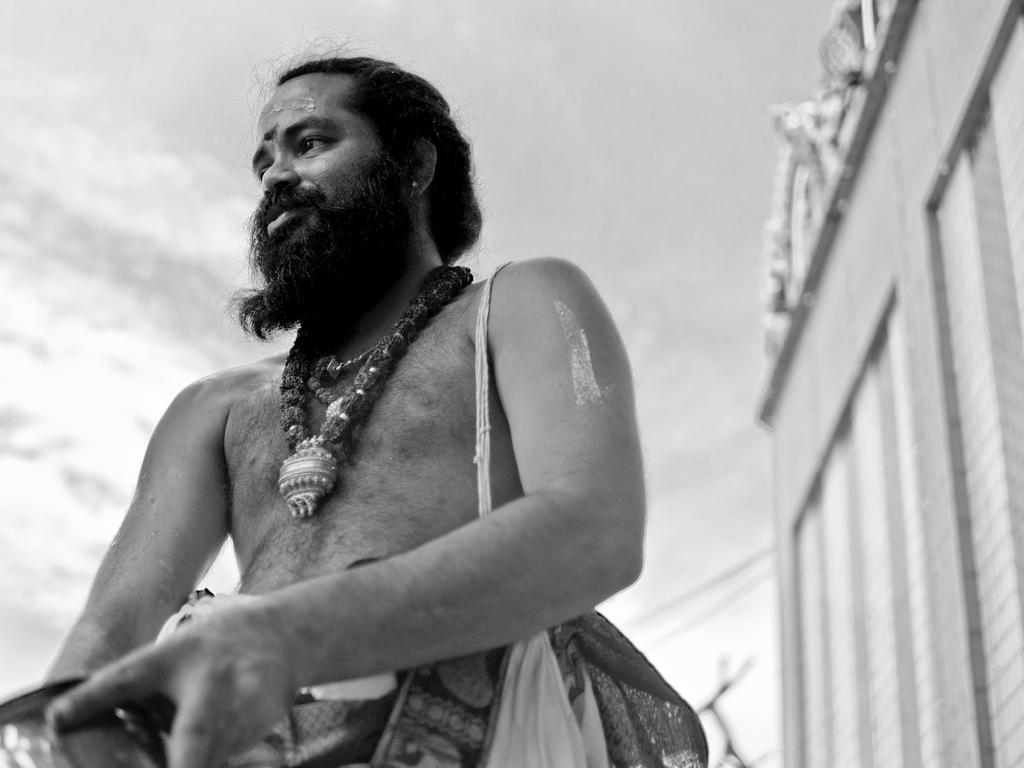Who is present in the image? There is a man in the image. What is the man carrying? The man is carrying a bag. What can be seen in the background of the image? There is a wall in the background of the image. How many beds are visible in the image? There are no beds present in the image. What type of vessel is the man using to carry his belongings? The man is carrying a bag, not a vessel, in the image. 